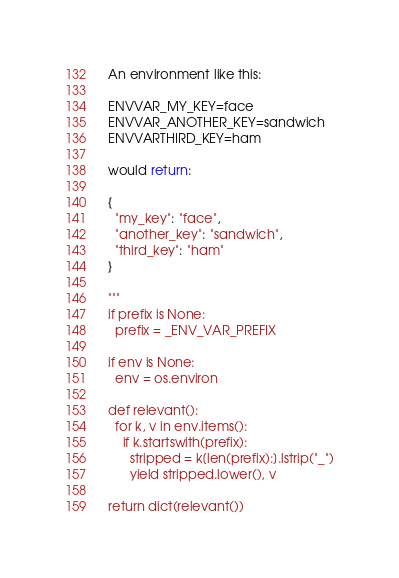<code> <loc_0><loc_0><loc_500><loc_500><_Python_>  An environment like this:

  ENVVAR_MY_KEY=face
  ENVVAR_ANOTHER_KEY=sandwich
  ENVVARTHIRD_KEY=ham

  would return:

  {
    "my_key": "face",
    "another_key": "sandwich",
    "third_key": "ham"
  }

  """
  if prefix is None:
    prefix = _ENV_VAR_PREFIX

  if env is None:
    env = os.environ

  def relevant():
    for k, v in env.items():
      if k.startswith(prefix):
        stripped = k[len(prefix):].lstrip("_")
        yield stripped.lower(), v

  return dict(relevant())
</code> 